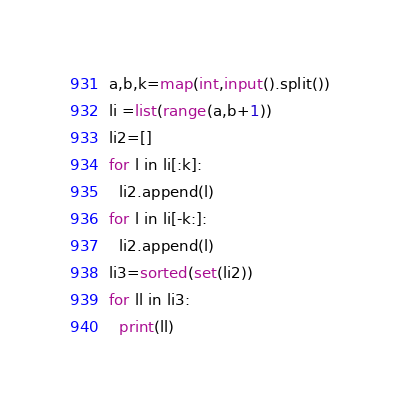Convert code to text. <code><loc_0><loc_0><loc_500><loc_500><_Python_>a,b,k=map(int,input().split())
li =list(range(a,b+1))
li2=[]
for l in li[:k]:
  li2.append(l)
for l in li[-k:]:
  li2.append(l)
li3=sorted(set(li2))
for ll in li3:
  print(ll)</code> 